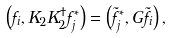<formula> <loc_0><loc_0><loc_500><loc_500>\left ( f _ { i } , K _ { 2 } K _ { 2 } ^ { \dagger } f _ { j } ^ { * } \right ) = \left ( \tilde { f } _ { j } ^ { * } , G \tilde { f } _ { i } \right ) ,</formula> 